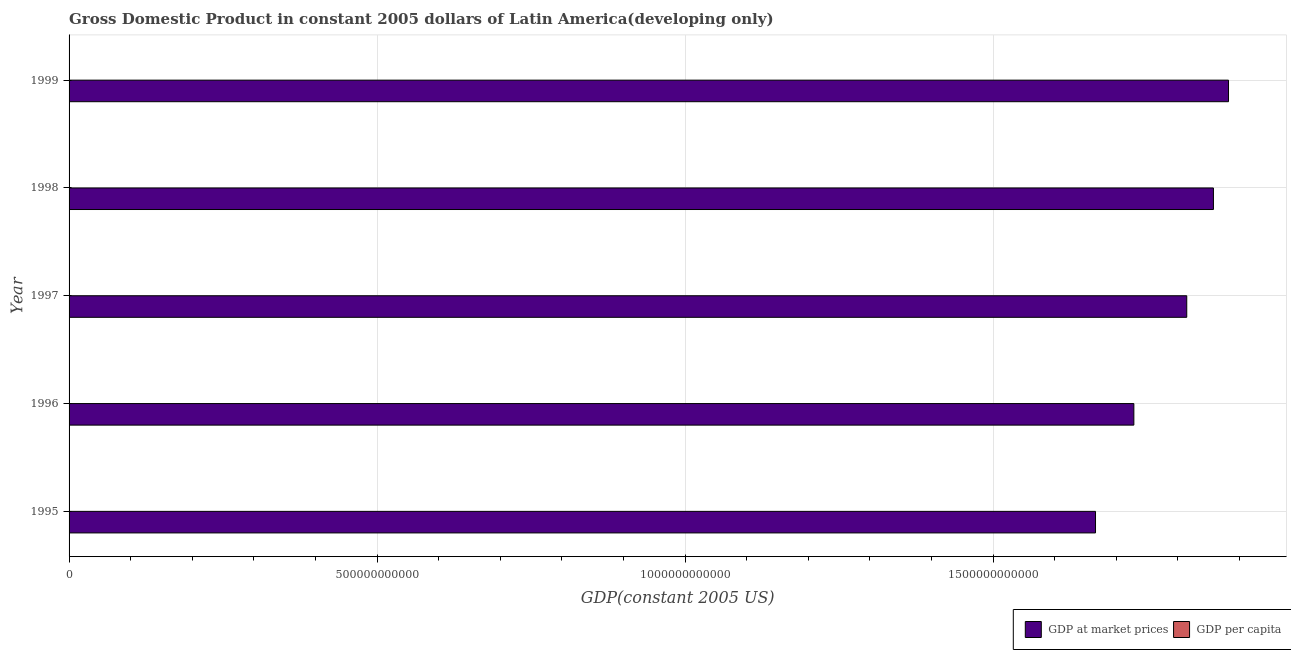How many different coloured bars are there?
Provide a succinct answer. 2. What is the gdp per capita in 1998?
Your response must be concise. 4358.09. Across all years, what is the maximum gdp per capita?
Offer a terse response. 4358.09. Across all years, what is the minimum gdp per capita?
Your answer should be very brief. 4107.09. What is the total gdp at market prices in the graph?
Your response must be concise. 8.95e+12. What is the difference between the gdp per capita in 1998 and that in 1999?
Offer a terse response. 11.21. What is the difference between the gdp at market prices in 1996 and the gdp per capita in 1999?
Keep it short and to the point. 1.73e+12. What is the average gdp at market prices per year?
Your answer should be compact. 1.79e+12. In the year 1997, what is the difference between the gdp at market prices and gdp per capita?
Give a very brief answer. 1.81e+12. In how many years, is the gdp at market prices greater than 100000000000 US$?
Your answer should be very brief. 5. What is the ratio of the gdp at market prices in 1996 to that in 1997?
Your answer should be compact. 0.95. Is the gdp at market prices in 1996 less than that in 1999?
Your answer should be compact. Yes. Is the difference between the gdp at market prices in 1998 and 1999 greater than the difference between the gdp per capita in 1998 and 1999?
Ensure brevity in your answer.  No. What is the difference between the highest and the second highest gdp per capita?
Offer a very short reply. 11.21. What is the difference between the highest and the lowest gdp at market prices?
Your response must be concise. 2.16e+11. In how many years, is the gdp per capita greater than the average gdp per capita taken over all years?
Offer a very short reply. 3. Is the sum of the gdp at market prices in 1995 and 1996 greater than the maximum gdp per capita across all years?
Make the answer very short. Yes. What does the 1st bar from the top in 1997 represents?
Offer a very short reply. GDP per capita. What does the 2nd bar from the bottom in 1999 represents?
Keep it short and to the point. GDP per capita. Are all the bars in the graph horizontal?
Ensure brevity in your answer.  Yes. How many years are there in the graph?
Offer a very short reply. 5. What is the difference between two consecutive major ticks on the X-axis?
Offer a very short reply. 5.00e+11. Where does the legend appear in the graph?
Your answer should be very brief. Bottom right. What is the title of the graph?
Your response must be concise. Gross Domestic Product in constant 2005 dollars of Latin America(developing only). What is the label or title of the X-axis?
Provide a short and direct response. GDP(constant 2005 US). What is the label or title of the Y-axis?
Offer a very short reply. Year. What is the GDP(constant 2005 US) in GDP at market prices in 1995?
Keep it short and to the point. 1.67e+12. What is the GDP(constant 2005 US) in GDP per capita in 1995?
Your response must be concise. 4107.09. What is the GDP(constant 2005 US) of GDP at market prices in 1996?
Offer a terse response. 1.73e+12. What is the GDP(constant 2005 US) in GDP per capita in 1996?
Provide a short and direct response. 4189.51. What is the GDP(constant 2005 US) in GDP at market prices in 1997?
Your answer should be very brief. 1.81e+12. What is the GDP(constant 2005 US) of GDP per capita in 1997?
Give a very brief answer. 4325.7. What is the GDP(constant 2005 US) of GDP at market prices in 1998?
Keep it short and to the point. 1.86e+12. What is the GDP(constant 2005 US) of GDP per capita in 1998?
Your answer should be very brief. 4358.09. What is the GDP(constant 2005 US) in GDP at market prices in 1999?
Provide a succinct answer. 1.88e+12. What is the GDP(constant 2005 US) in GDP per capita in 1999?
Provide a short and direct response. 4346.88. Across all years, what is the maximum GDP(constant 2005 US) of GDP at market prices?
Offer a terse response. 1.88e+12. Across all years, what is the maximum GDP(constant 2005 US) in GDP per capita?
Keep it short and to the point. 4358.09. Across all years, what is the minimum GDP(constant 2005 US) in GDP at market prices?
Your answer should be very brief. 1.67e+12. Across all years, what is the minimum GDP(constant 2005 US) in GDP per capita?
Ensure brevity in your answer.  4107.09. What is the total GDP(constant 2005 US) in GDP at market prices in the graph?
Provide a short and direct response. 8.95e+12. What is the total GDP(constant 2005 US) of GDP per capita in the graph?
Ensure brevity in your answer.  2.13e+04. What is the difference between the GDP(constant 2005 US) of GDP at market prices in 1995 and that in 1996?
Your answer should be very brief. -6.22e+1. What is the difference between the GDP(constant 2005 US) in GDP per capita in 1995 and that in 1996?
Keep it short and to the point. -82.41. What is the difference between the GDP(constant 2005 US) in GDP at market prices in 1995 and that in 1997?
Your answer should be very brief. -1.48e+11. What is the difference between the GDP(constant 2005 US) of GDP per capita in 1995 and that in 1997?
Ensure brevity in your answer.  -218.61. What is the difference between the GDP(constant 2005 US) in GDP at market prices in 1995 and that in 1998?
Offer a terse response. -1.91e+11. What is the difference between the GDP(constant 2005 US) of GDP per capita in 1995 and that in 1998?
Your answer should be very brief. -251. What is the difference between the GDP(constant 2005 US) in GDP at market prices in 1995 and that in 1999?
Your answer should be very brief. -2.16e+11. What is the difference between the GDP(constant 2005 US) of GDP per capita in 1995 and that in 1999?
Make the answer very short. -239.78. What is the difference between the GDP(constant 2005 US) in GDP at market prices in 1996 and that in 1997?
Your answer should be compact. -8.59e+1. What is the difference between the GDP(constant 2005 US) of GDP per capita in 1996 and that in 1997?
Offer a terse response. -136.19. What is the difference between the GDP(constant 2005 US) in GDP at market prices in 1996 and that in 1998?
Your answer should be very brief. -1.29e+11. What is the difference between the GDP(constant 2005 US) of GDP per capita in 1996 and that in 1998?
Provide a short and direct response. -168.58. What is the difference between the GDP(constant 2005 US) in GDP at market prices in 1996 and that in 1999?
Offer a terse response. -1.54e+11. What is the difference between the GDP(constant 2005 US) in GDP per capita in 1996 and that in 1999?
Offer a very short reply. -157.37. What is the difference between the GDP(constant 2005 US) of GDP at market prices in 1997 and that in 1998?
Provide a succinct answer. -4.33e+1. What is the difference between the GDP(constant 2005 US) of GDP per capita in 1997 and that in 1998?
Provide a succinct answer. -32.39. What is the difference between the GDP(constant 2005 US) of GDP at market prices in 1997 and that in 1999?
Your answer should be very brief. -6.78e+1. What is the difference between the GDP(constant 2005 US) of GDP per capita in 1997 and that in 1999?
Provide a short and direct response. -21.17. What is the difference between the GDP(constant 2005 US) of GDP at market prices in 1998 and that in 1999?
Make the answer very short. -2.45e+1. What is the difference between the GDP(constant 2005 US) in GDP per capita in 1998 and that in 1999?
Your answer should be very brief. 11.21. What is the difference between the GDP(constant 2005 US) of GDP at market prices in 1995 and the GDP(constant 2005 US) of GDP per capita in 1996?
Your answer should be compact. 1.67e+12. What is the difference between the GDP(constant 2005 US) of GDP at market prices in 1995 and the GDP(constant 2005 US) of GDP per capita in 1997?
Ensure brevity in your answer.  1.67e+12. What is the difference between the GDP(constant 2005 US) of GDP at market prices in 1995 and the GDP(constant 2005 US) of GDP per capita in 1998?
Give a very brief answer. 1.67e+12. What is the difference between the GDP(constant 2005 US) of GDP at market prices in 1995 and the GDP(constant 2005 US) of GDP per capita in 1999?
Make the answer very short. 1.67e+12. What is the difference between the GDP(constant 2005 US) of GDP at market prices in 1996 and the GDP(constant 2005 US) of GDP per capita in 1997?
Offer a terse response. 1.73e+12. What is the difference between the GDP(constant 2005 US) in GDP at market prices in 1996 and the GDP(constant 2005 US) in GDP per capita in 1998?
Provide a succinct answer. 1.73e+12. What is the difference between the GDP(constant 2005 US) in GDP at market prices in 1996 and the GDP(constant 2005 US) in GDP per capita in 1999?
Give a very brief answer. 1.73e+12. What is the difference between the GDP(constant 2005 US) of GDP at market prices in 1997 and the GDP(constant 2005 US) of GDP per capita in 1998?
Ensure brevity in your answer.  1.81e+12. What is the difference between the GDP(constant 2005 US) in GDP at market prices in 1997 and the GDP(constant 2005 US) in GDP per capita in 1999?
Your answer should be very brief. 1.81e+12. What is the difference between the GDP(constant 2005 US) of GDP at market prices in 1998 and the GDP(constant 2005 US) of GDP per capita in 1999?
Your answer should be very brief. 1.86e+12. What is the average GDP(constant 2005 US) in GDP at market prices per year?
Provide a short and direct response. 1.79e+12. What is the average GDP(constant 2005 US) of GDP per capita per year?
Your response must be concise. 4265.45. In the year 1995, what is the difference between the GDP(constant 2005 US) in GDP at market prices and GDP(constant 2005 US) in GDP per capita?
Your response must be concise. 1.67e+12. In the year 1996, what is the difference between the GDP(constant 2005 US) of GDP at market prices and GDP(constant 2005 US) of GDP per capita?
Offer a very short reply. 1.73e+12. In the year 1997, what is the difference between the GDP(constant 2005 US) in GDP at market prices and GDP(constant 2005 US) in GDP per capita?
Your response must be concise. 1.81e+12. In the year 1998, what is the difference between the GDP(constant 2005 US) of GDP at market prices and GDP(constant 2005 US) of GDP per capita?
Offer a very short reply. 1.86e+12. In the year 1999, what is the difference between the GDP(constant 2005 US) of GDP at market prices and GDP(constant 2005 US) of GDP per capita?
Your response must be concise. 1.88e+12. What is the ratio of the GDP(constant 2005 US) in GDP per capita in 1995 to that in 1996?
Make the answer very short. 0.98. What is the ratio of the GDP(constant 2005 US) of GDP at market prices in 1995 to that in 1997?
Your response must be concise. 0.92. What is the ratio of the GDP(constant 2005 US) in GDP per capita in 1995 to that in 1997?
Your answer should be compact. 0.95. What is the ratio of the GDP(constant 2005 US) of GDP at market prices in 1995 to that in 1998?
Keep it short and to the point. 0.9. What is the ratio of the GDP(constant 2005 US) in GDP per capita in 1995 to that in 1998?
Offer a terse response. 0.94. What is the ratio of the GDP(constant 2005 US) of GDP at market prices in 1995 to that in 1999?
Offer a very short reply. 0.89. What is the ratio of the GDP(constant 2005 US) in GDP per capita in 1995 to that in 1999?
Provide a short and direct response. 0.94. What is the ratio of the GDP(constant 2005 US) of GDP at market prices in 1996 to that in 1997?
Ensure brevity in your answer.  0.95. What is the ratio of the GDP(constant 2005 US) of GDP per capita in 1996 to that in 1997?
Your answer should be very brief. 0.97. What is the ratio of the GDP(constant 2005 US) of GDP at market prices in 1996 to that in 1998?
Give a very brief answer. 0.93. What is the ratio of the GDP(constant 2005 US) in GDP per capita in 1996 to that in 1998?
Your answer should be compact. 0.96. What is the ratio of the GDP(constant 2005 US) in GDP at market prices in 1996 to that in 1999?
Provide a succinct answer. 0.92. What is the ratio of the GDP(constant 2005 US) in GDP per capita in 1996 to that in 1999?
Your answer should be very brief. 0.96. What is the ratio of the GDP(constant 2005 US) of GDP at market prices in 1997 to that in 1998?
Ensure brevity in your answer.  0.98. What is the ratio of the GDP(constant 2005 US) of GDP per capita in 1997 to that in 1998?
Offer a very short reply. 0.99. What is the difference between the highest and the second highest GDP(constant 2005 US) of GDP at market prices?
Your response must be concise. 2.45e+1. What is the difference between the highest and the second highest GDP(constant 2005 US) in GDP per capita?
Give a very brief answer. 11.21. What is the difference between the highest and the lowest GDP(constant 2005 US) of GDP at market prices?
Your response must be concise. 2.16e+11. What is the difference between the highest and the lowest GDP(constant 2005 US) in GDP per capita?
Your answer should be very brief. 251. 